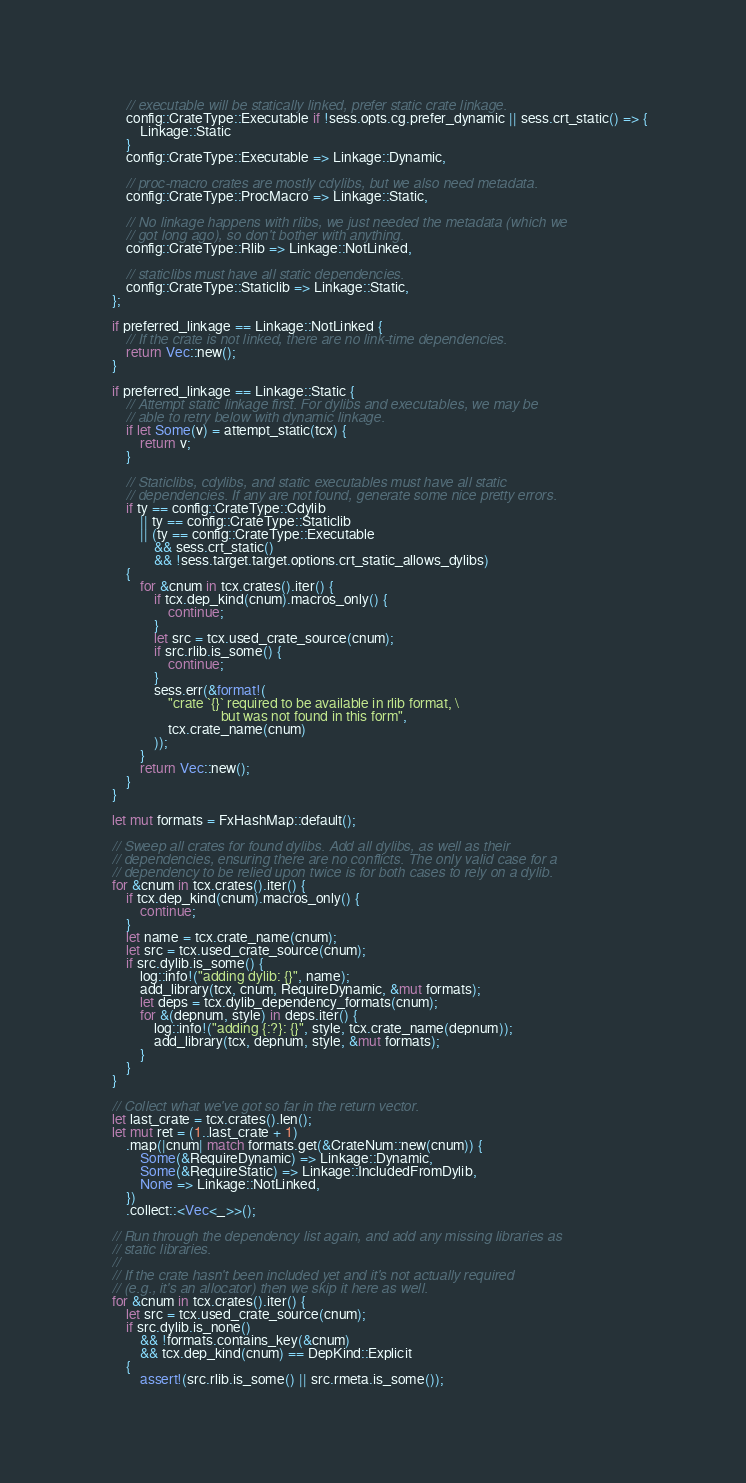Convert code to text. <code><loc_0><loc_0><loc_500><loc_500><_Rust_>        // executable will be statically linked, prefer static crate linkage.
        config::CrateType::Executable if !sess.opts.cg.prefer_dynamic || sess.crt_static() => {
            Linkage::Static
        }
        config::CrateType::Executable => Linkage::Dynamic,

        // proc-macro crates are mostly cdylibs, but we also need metadata.
        config::CrateType::ProcMacro => Linkage::Static,

        // No linkage happens with rlibs, we just needed the metadata (which we
        // got long ago), so don't bother with anything.
        config::CrateType::Rlib => Linkage::NotLinked,

        // staticlibs must have all static dependencies.
        config::CrateType::Staticlib => Linkage::Static,
    };

    if preferred_linkage == Linkage::NotLinked {
        // If the crate is not linked, there are no link-time dependencies.
        return Vec::new();
    }

    if preferred_linkage == Linkage::Static {
        // Attempt static linkage first. For dylibs and executables, we may be
        // able to retry below with dynamic linkage.
        if let Some(v) = attempt_static(tcx) {
            return v;
        }

        // Staticlibs, cdylibs, and static executables must have all static
        // dependencies. If any are not found, generate some nice pretty errors.
        if ty == config::CrateType::Cdylib
            || ty == config::CrateType::Staticlib
            || (ty == config::CrateType::Executable
                && sess.crt_static()
                && !sess.target.target.options.crt_static_allows_dylibs)
        {
            for &cnum in tcx.crates().iter() {
                if tcx.dep_kind(cnum).macros_only() {
                    continue;
                }
                let src = tcx.used_crate_source(cnum);
                if src.rlib.is_some() {
                    continue;
                }
                sess.err(&format!(
                    "crate `{}` required to be available in rlib format, \
                                   but was not found in this form",
                    tcx.crate_name(cnum)
                ));
            }
            return Vec::new();
        }
    }

    let mut formats = FxHashMap::default();

    // Sweep all crates for found dylibs. Add all dylibs, as well as their
    // dependencies, ensuring there are no conflicts. The only valid case for a
    // dependency to be relied upon twice is for both cases to rely on a dylib.
    for &cnum in tcx.crates().iter() {
        if tcx.dep_kind(cnum).macros_only() {
            continue;
        }
        let name = tcx.crate_name(cnum);
        let src = tcx.used_crate_source(cnum);
        if src.dylib.is_some() {
            log::info!("adding dylib: {}", name);
            add_library(tcx, cnum, RequireDynamic, &mut formats);
            let deps = tcx.dylib_dependency_formats(cnum);
            for &(depnum, style) in deps.iter() {
                log::info!("adding {:?}: {}", style, tcx.crate_name(depnum));
                add_library(tcx, depnum, style, &mut formats);
            }
        }
    }

    // Collect what we've got so far in the return vector.
    let last_crate = tcx.crates().len();
    let mut ret = (1..last_crate + 1)
        .map(|cnum| match formats.get(&CrateNum::new(cnum)) {
            Some(&RequireDynamic) => Linkage::Dynamic,
            Some(&RequireStatic) => Linkage::IncludedFromDylib,
            None => Linkage::NotLinked,
        })
        .collect::<Vec<_>>();

    // Run through the dependency list again, and add any missing libraries as
    // static libraries.
    //
    // If the crate hasn't been included yet and it's not actually required
    // (e.g., it's an allocator) then we skip it here as well.
    for &cnum in tcx.crates().iter() {
        let src = tcx.used_crate_source(cnum);
        if src.dylib.is_none()
            && !formats.contains_key(&cnum)
            && tcx.dep_kind(cnum) == DepKind::Explicit
        {
            assert!(src.rlib.is_some() || src.rmeta.is_some());</code> 